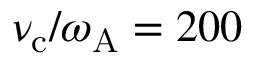Convert formula to latex. <formula><loc_0><loc_0><loc_500><loc_500>\nu _ { c } / \omega _ { A } = 2 0 0</formula> 